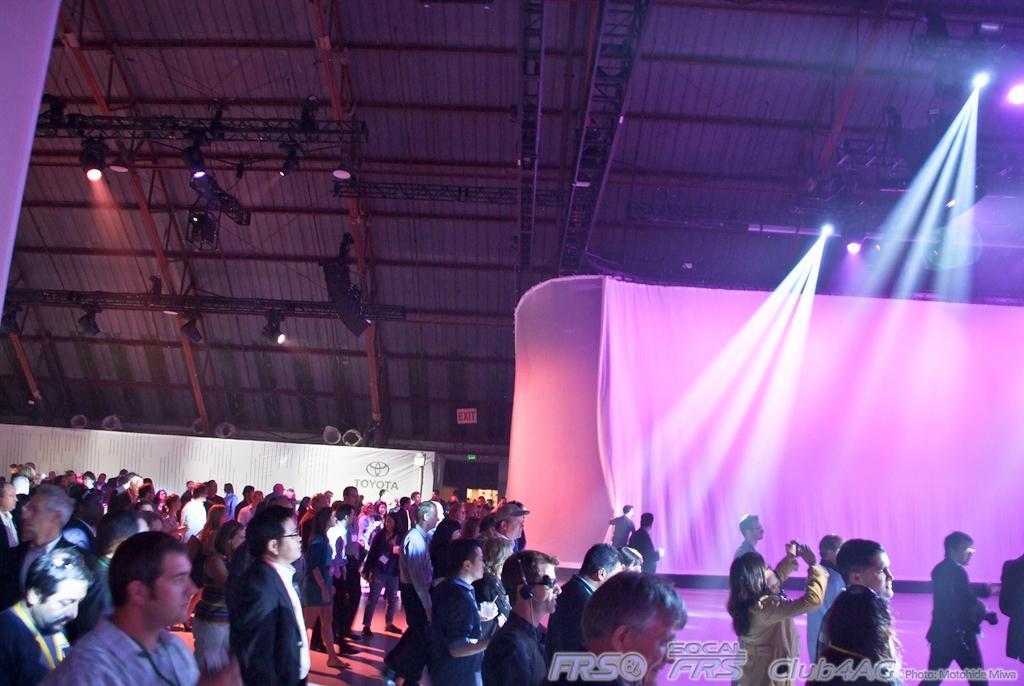Describe this image in one or two sentences. In this image in the front there are group of persons standing and walking. On the top there are lights. In the background there is a curtain and on the left side there is an object which is white in colour with some text written on it. 